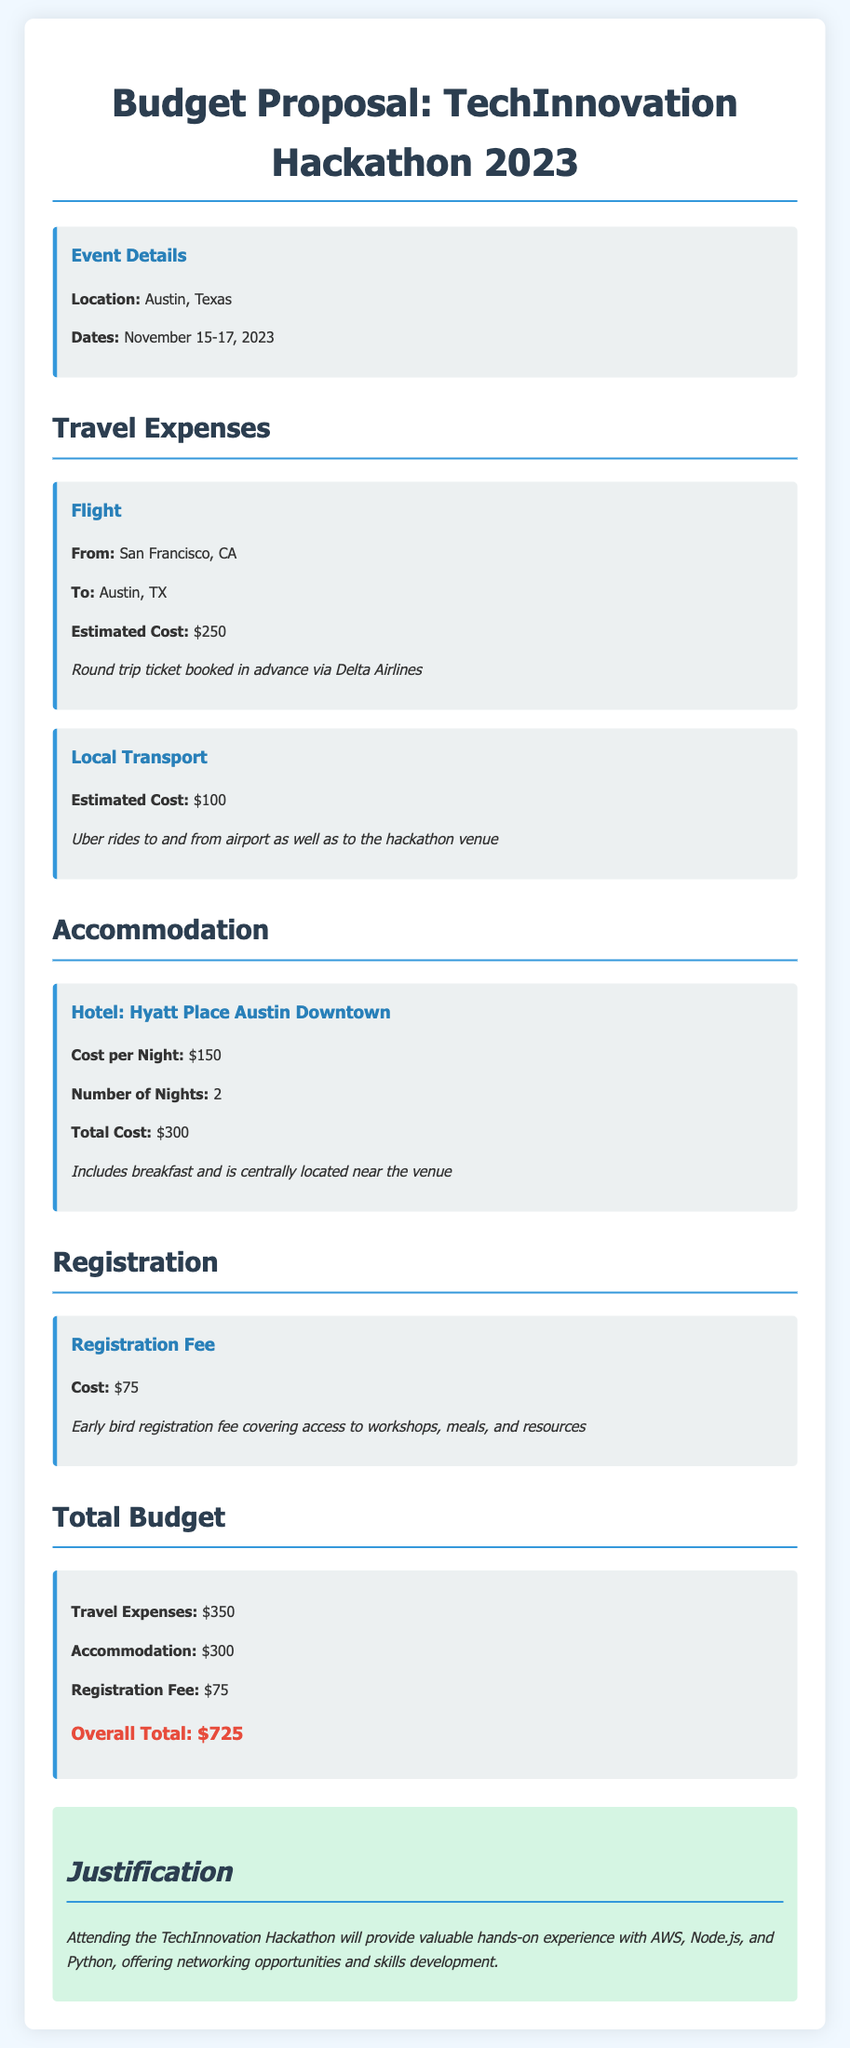What is the location of the hackathon? The location of the hackathon is stated as Austin, Texas in the event details section.
Answer: Austin, Texas What is the total budget? The total budget is calculated as the sum of travel expenses, accommodation, and registration fee, which amounts to $725.
Answer: $725 How much is the registration fee? The registration fee is explicitly mentioned in the registration section of the document as $75.
Answer: $75 When is the hackathon taking place? The dates for the hackathon are provided, which are November 15-17, 2023.
Answer: November 15-17, 2023 What is the estimated cost for local transport? The document specifies the estimated cost for local transport as $100.
Answer: $100 How many nights will accommodation be needed? The budget proposal indicates that accommodation is needed for 2 nights at the hotel.
Answer: 2 What is the cost per night for accommodation? The budget states that the cost per night at the hotel is $150.
Answer: $150 What type of hotel is being booked? The hotel being booked is named Hyatt Place Austin Downtown as listed under accommodation.
Answer: Hyatt Place Austin Downtown What is one benefit of attending the hackathon mentioned in the justification? The justification highlights that attending the hackathon will provide valuable hands-on experience with AWS, Node.js, and Python.
Answer: valuable hands-on experience 